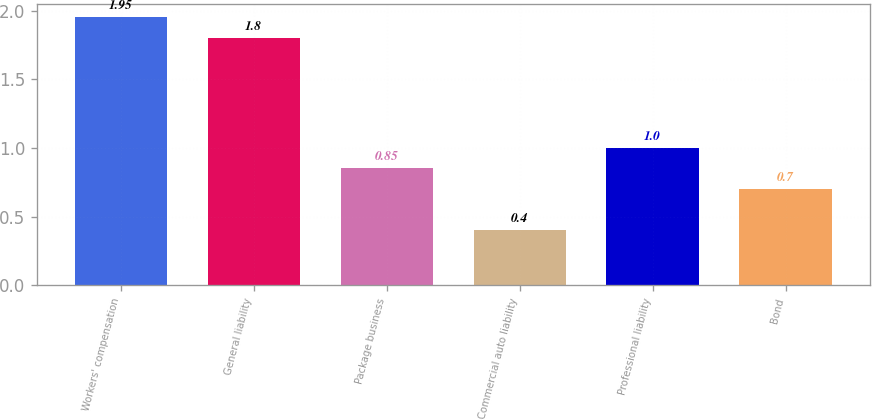Convert chart. <chart><loc_0><loc_0><loc_500><loc_500><bar_chart><fcel>Workers' compensation<fcel>General liability<fcel>Package business<fcel>Commercial auto liability<fcel>Professional liability<fcel>Bond<nl><fcel>1.95<fcel>1.8<fcel>0.85<fcel>0.4<fcel>1<fcel>0.7<nl></chart> 